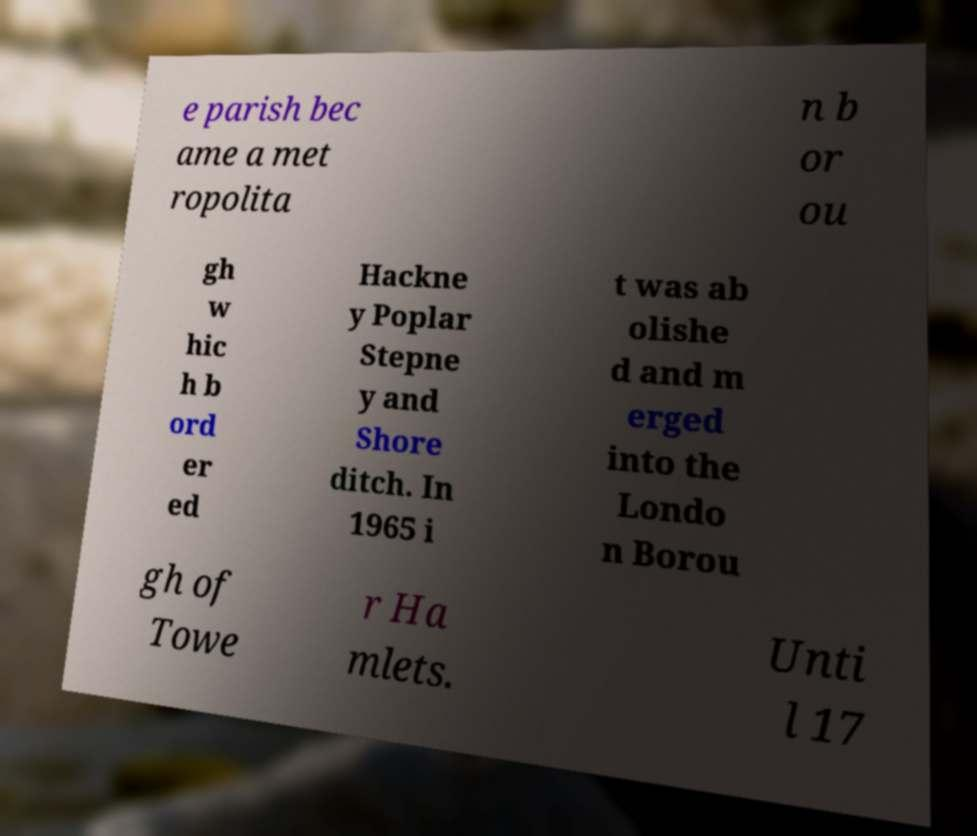Please read and relay the text visible in this image. What does it say? e parish bec ame a met ropolita n b or ou gh w hic h b ord er ed Hackne y Poplar Stepne y and Shore ditch. In 1965 i t was ab olishe d and m erged into the Londo n Borou gh of Towe r Ha mlets. Unti l 17 